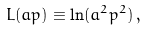Convert formula to latex. <formula><loc_0><loc_0><loc_500><loc_500>L ( a p ) \equiv \ln ( a ^ { 2 } p ^ { 2 } ) \, ,</formula> 